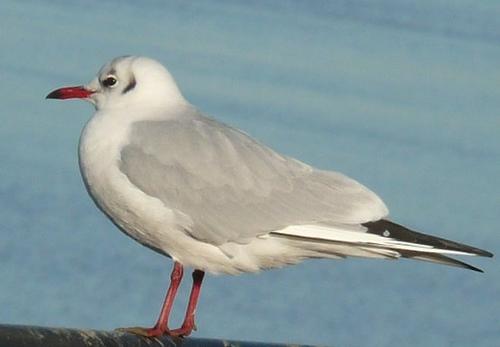What are the birds standing on?
Answer briefly. Fence. How many breaks are there?
Give a very brief answer. 1. What kind of bird is it?
Short answer required. Seagull. Is the bird flying?
Concise answer only. No. How many birds are in the picture?
Write a very short answer. 1. How many birds are there?
Answer briefly. 1. What color head does this bird have?
Quick response, please. White. What color is the bird?
Keep it brief. White. What is in the background?
Short answer required. Water. 